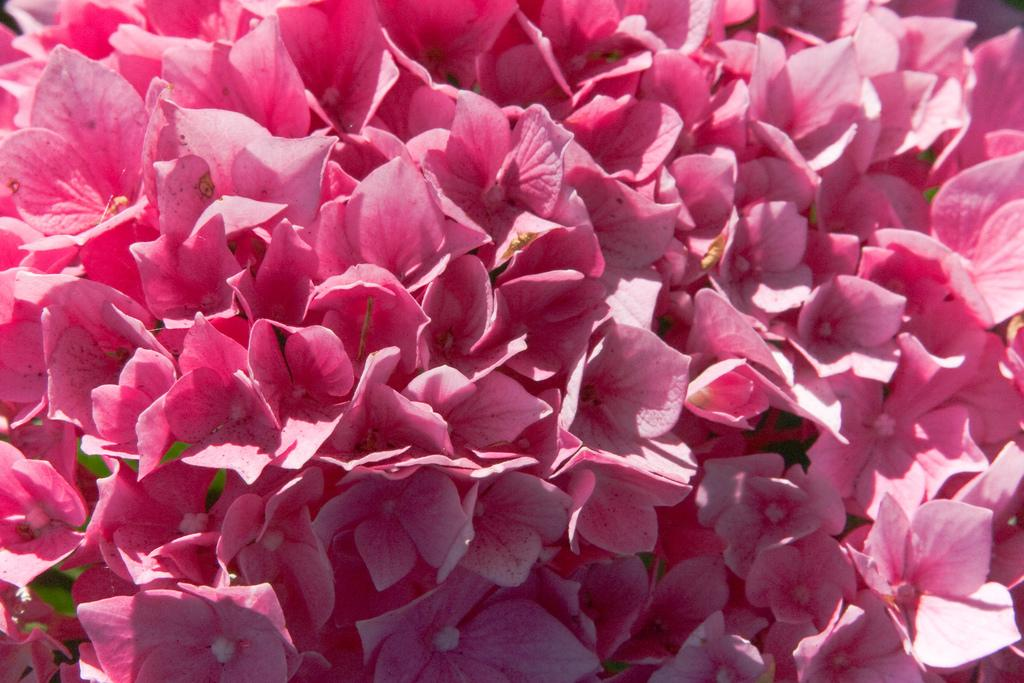What is the main subject of the image? There is a blossom in the center of the image. Can you describe the blossom in more detail? Unfortunately, the provided facts do not offer any additional details about the blossom. What might be the significance of the blossom in the image? Without further context, it is difficult to determine the significance of the blossom in the image. How many seeds can be seen inside the blossom in the image? There is no information provided about the presence or number of seeds in the blossom. What type of belief system is represented by the blossom in the image? There is no information provided about any belief system or symbolism associated with the blossom. 